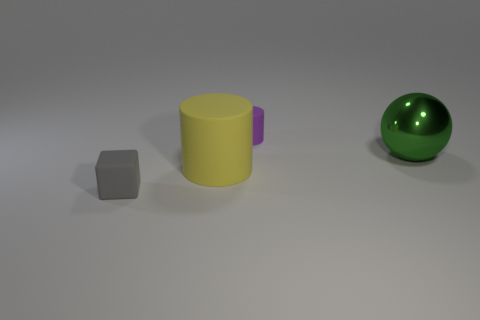Add 4 yellow things. How many objects exist? 8 Subtract all cubes. How many objects are left? 3 Subtract 1 balls. How many balls are left? 0 Subtract all blue cylinders. Subtract all blue balls. How many cylinders are left? 2 Subtract all blue blocks. How many yellow cylinders are left? 1 Subtract all tiny rubber cylinders. Subtract all matte objects. How many objects are left? 0 Add 3 large metal spheres. How many large metal spheres are left? 4 Add 1 big brown rubber cubes. How many big brown rubber cubes exist? 1 Subtract 0 cyan cylinders. How many objects are left? 4 